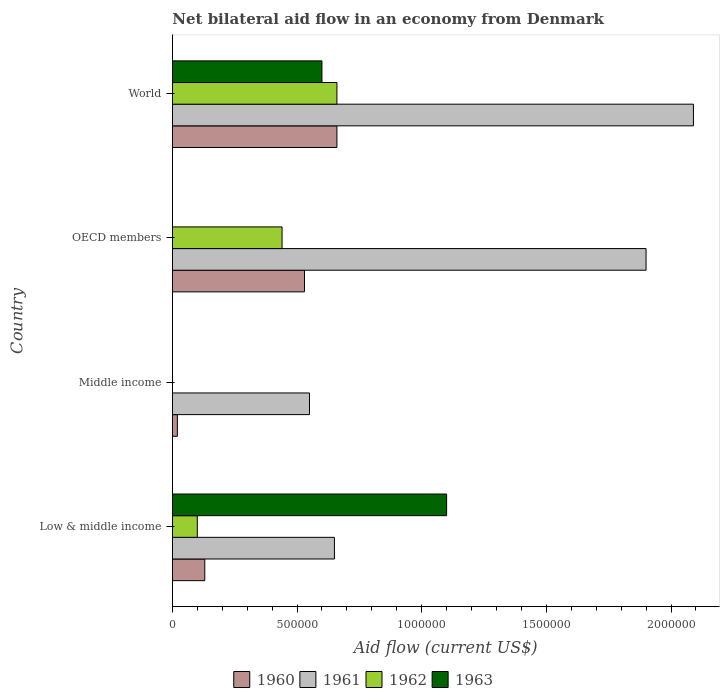What is the net bilateral aid flow in 1961 in OECD members?
Your response must be concise. 1.90e+06. Across all countries, what is the maximum net bilateral aid flow in 1963?
Provide a succinct answer. 1.10e+06. What is the total net bilateral aid flow in 1962 in the graph?
Your response must be concise. 1.20e+06. What is the difference between the net bilateral aid flow in 1961 in Middle income and that in World?
Your response must be concise. -1.54e+06. What is the average net bilateral aid flow in 1961 per country?
Make the answer very short. 1.30e+06. What is the difference between the net bilateral aid flow in 1963 and net bilateral aid flow in 1960 in Low & middle income?
Offer a very short reply. 9.70e+05. What is the ratio of the net bilateral aid flow in 1961 in Middle income to that in OECD members?
Provide a succinct answer. 0.29. What is the difference between the highest and the second highest net bilateral aid flow in 1961?
Offer a terse response. 1.90e+05. What is the difference between the highest and the lowest net bilateral aid flow in 1960?
Your answer should be very brief. 6.40e+05. Is the sum of the net bilateral aid flow in 1960 in Low & middle income and OECD members greater than the maximum net bilateral aid flow in 1961 across all countries?
Provide a succinct answer. No. How many bars are there?
Give a very brief answer. 13. How many countries are there in the graph?
Give a very brief answer. 4. Are the values on the major ticks of X-axis written in scientific E-notation?
Your response must be concise. No. Does the graph contain any zero values?
Make the answer very short. Yes. Where does the legend appear in the graph?
Your answer should be very brief. Bottom center. What is the title of the graph?
Ensure brevity in your answer.  Net bilateral aid flow in an economy from Denmark. What is the Aid flow (current US$) in 1961 in Low & middle income?
Offer a terse response. 6.50e+05. What is the Aid flow (current US$) in 1963 in Low & middle income?
Give a very brief answer. 1.10e+06. What is the Aid flow (current US$) in 1960 in Middle income?
Provide a succinct answer. 2.00e+04. What is the Aid flow (current US$) in 1960 in OECD members?
Provide a short and direct response. 5.30e+05. What is the Aid flow (current US$) of 1961 in OECD members?
Your answer should be compact. 1.90e+06. What is the Aid flow (current US$) in 1961 in World?
Your answer should be compact. 2.09e+06. What is the Aid flow (current US$) of 1962 in World?
Keep it short and to the point. 6.60e+05. What is the Aid flow (current US$) of 1963 in World?
Your response must be concise. 6.00e+05. Across all countries, what is the maximum Aid flow (current US$) in 1961?
Your answer should be very brief. 2.09e+06. Across all countries, what is the maximum Aid flow (current US$) of 1962?
Offer a very short reply. 6.60e+05. Across all countries, what is the maximum Aid flow (current US$) in 1963?
Make the answer very short. 1.10e+06. Across all countries, what is the minimum Aid flow (current US$) in 1960?
Offer a very short reply. 2.00e+04. Across all countries, what is the minimum Aid flow (current US$) in 1961?
Your answer should be compact. 5.50e+05. Across all countries, what is the minimum Aid flow (current US$) of 1962?
Your response must be concise. 0. Across all countries, what is the minimum Aid flow (current US$) in 1963?
Offer a very short reply. 0. What is the total Aid flow (current US$) of 1960 in the graph?
Your answer should be compact. 1.34e+06. What is the total Aid flow (current US$) of 1961 in the graph?
Your response must be concise. 5.19e+06. What is the total Aid flow (current US$) in 1962 in the graph?
Your response must be concise. 1.20e+06. What is the total Aid flow (current US$) in 1963 in the graph?
Your response must be concise. 1.70e+06. What is the difference between the Aid flow (current US$) in 1960 in Low & middle income and that in Middle income?
Ensure brevity in your answer.  1.10e+05. What is the difference between the Aid flow (current US$) of 1960 in Low & middle income and that in OECD members?
Provide a short and direct response. -4.00e+05. What is the difference between the Aid flow (current US$) in 1961 in Low & middle income and that in OECD members?
Ensure brevity in your answer.  -1.25e+06. What is the difference between the Aid flow (current US$) of 1960 in Low & middle income and that in World?
Provide a succinct answer. -5.30e+05. What is the difference between the Aid flow (current US$) of 1961 in Low & middle income and that in World?
Your answer should be very brief. -1.44e+06. What is the difference between the Aid flow (current US$) in 1962 in Low & middle income and that in World?
Your response must be concise. -5.60e+05. What is the difference between the Aid flow (current US$) of 1963 in Low & middle income and that in World?
Your answer should be compact. 5.00e+05. What is the difference between the Aid flow (current US$) of 1960 in Middle income and that in OECD members?
Your response must be concise. -5.10e+05. What is the difference between the Aid flow (current US$) in 1961 in Middle income and that in OECD members?
Make the answer very short. -1.35e+06. What is the difference between the Aid flow (current US$) of 1960 in Middle income and that in World?
Provide a succinct answer. -6.40e+05. What is the difference between the Aid flow (current US$) of 1961 in Middle income and that in World?
Offer a very short reply. -1.54e+06. What is the difference between the Aid flow (current US$) in 1960 in OECD members and that in World?
Provide a short and direct response. -1.30e+05. What is the difference between the Aid flow (current US$) of 1960 in Low & middle income and the Aid flow (current US$) of 1961 in Middle income?
Your response must be concise. -4.20e+05. What is the difference between the Aid flow (current US$) in 1960 in Low & middle income and the Aid flow (current US$) in 1961 in OECD members?
Your response must be concise. -1.77e+06. What is the difference between the Aid flow (current US$) in 1960 in Low & middle income and the Aid flow (current US$) in 1962 in OECD members?
Give a very brief answer. -3.10e+05. What is the difference between the Aid flow (current US$) of 1961 in Low & middle income and the Aid flow (current US$) of 1962 in OECD members?
Ensure brevity in your answer.  2.10e+05. What is the difference between the Aid flow (current US$) of 1960 in Low & middle income and the Aid flow (current US$) of 1961 in World?
Give a very brief answer. -1.96e+06. What is the difference between the Aid flow (current US$) in 1960 in Low & middle income and the Aid flow (current US$) in 1962 in World?
Your answer should be compact. -5.30e+05. What is the difference between the Aid flow (current US$) in 1960 in Low & middle income and the Aid flow (current US$) in 1963 in World?
Give a very brief answer. -4.70e+05. What is the difference between the Aid flow (current US$) of 1962 in Low & middle income and the Aid flow (current US$) of 1963 in World?
Give a very brief answer. -5.00e+05. What is the difference between the Aid flow (current US$) in 1960 in Middle income and the Aid flow (current US$) in 1961 in OECD members?
Make the answer very short. -1.88e+06. What is the difference between the Aid flow (current US$) of 1960 in Middle income and the Aid flow (current US$) of 1962 in OECD members?
Make the answer very short. -4.20e+05. What is the difference between the Aid flow (current US$) of 1961 in Middle income and the Aid flow (current US$) of 1962 in OECD members?
Ensure brevity in your answer.  1.10e+05. What is the difference between the Aid flow (current US$) of 1960 in Middle income and the Aid flow (current US$) of 1961 in World?
Keep it short and to the point. -2.07e+06. What is the difference between the Aid flow (current US$) of 1960 in Middle income and the Aid flow (current US$) of 1962 in World?
Offer a very short reply. -6.40e+05. What is the difference between the Aid flow (current US$) of 1960 in Middle income and the Aid flow (current US$) of 1963 in World?
Provide a succinct answer. -5.80e+05. What is the difference between the Aid flow (current US$) in 1961 in Middle income and the Aid flow (current US$) in 1962 in World?
Your response must be concise. -1.10e+05. What is the difference between the Aid flow (current US$) of 1961 in Middle income and the Aid flow (current US$) of 1963 in World?
Offer a terse response. -5.00e+04. What is the difference between the Aid flow (current US$) in 1960 in OECD members and the Aid flow (current US$) in 1961 in World?
Give a very brief answer. -1.56e+06. What is the difference between the Aid flow (current US$) of 1960 in OECD members and the Aid flow (current US$) of 1962 in World?
Provide a succinct answer. -1.30e+05. What is the difference between the Aid flow (current US$) in 1960 in OECD members and the Aid flow (current US$) in 1963 in World?
Offer a terse response. -7.00e+04. What is the difference between the Aid flow (current US$) of 1961 in OECD members and the Aid flow (current US$) of 1962 in World?
Provide a succinct answer. 1.24e+06. What is the difference between the Aid flow (current US$) of 1961 in OECD members and the Aid flow (current US$) of 1963 in World?
Ensure brevity in your answer.  1.30e+06. What is the average Aid flow (current US$) of 1960 per country?
Make the answer very short. 3.35e+05. What is the average Aid flow (current US$) in 1961 per country?
Your response must be concise. 1.30e+06. What is the average Aid flow (current US$) in 1962 per country?
Make the answer very short. 3.00e+05. What is the average Aid flow (current US$) of 1963 per country?
Make the answer very short. 4.25e+05. What is the difference between the Aid flow (current US$) in 1960 and Aid flow (current US$) in 1961 in Low & middle income?
Offer a terse response. -5.20e+05. What is the difference between the Aid flow (current US$) in 1960 and Aid flow (current US$) in 1963 in Low & middle income?
Offer a terse response. -9.70e+05. What is the difference between the Aid flow (current US$) in 1961 and Aid flow (current US$) in 1962 in Low & middle income?
Your response must be concise. 5.50e+05. What is the difference between the Aid flow (current US$) in 1961 and Aid flow (current US$) in 1963 in Low & middle income?
Offer a terse response. -4.50e+05. What is the difference between the Aid flow (current US$) of 1960 and Aid flow (current US$) of 1961 in Middle income?
Keep it short and to the point. -5.30e+05. What is the difference between the Aid flow (current US$) in 1960 and Aid flow (current US$) in 1961 in OECD members?
Ensure brevity in your answer.  -1.37e+06. What is the difference between the Aid flow (current US$) in 1961 and Aid flow (current US$) in 1962 in OECD members?
Ensure brevity in your answer.  1.46e+06. What is the difference between the Aid flow (current US$) in 1960 and Aid flow (current US$) in 1961 in World?
Offer a terse response. -1.43e+06. What is the difference between the Aid flow (current US$) in 1961 and Aid flow (current US$) in 1962 in World?
Ensure brevity in your answer.  1.43e+06. What is the difference between the Aid flow (current US$) in 1961 and Aid flow (current US$) in 1963 in World?
Make the answer very short. 1.49e+06. What is the difference between the Aid flow (current US$) in 1962 and Aid flow (current US$) in 1963 in World?
Give a very brief answer. 6.00e+04. What is the ratio of the Aid flow (current US$) in 1960 in Low & middle income to that in Middle income?
Your response must be concise. 6.5. What is the ratio of the Aid flow (current US$) of 1961 in Low & middle income to that in Middle income?
Keep it short and to the point. 1.18. What is the ratio of the Aid flow (current US$) in 1960 in Low & middle income to that in OECD members?
Keep it short and to the point. 0.25. What is the ratio of the Aid flow (current US$) of 1961 in Low & middle income to that in OECD members?
Offer a very short reply. 0.34. What is the ratio of the Aid flow (current US$) of 1962 in Low & middle income to that in OECD members?
Make the answer very short. 0.23. What is the ratio of the Aid flow (current US$) of 1960 in Low & middle income to that in World?
Your answer should be very brief. 0.2. What is the ratio of the Aid flow (current US$) in 1961 in Low & middle income to that in World?
Offer a very short reply. 0.31. What is the ratio of the Aid flow (current US$) of 1962 in Low & middle income to that in World?
Your answer should be very brief. 0.15. What is the ratio of the Aid flow (current US$) of 1963 in Low & middle income to that in World?
Ensure brevity in your answer.  1.83. What is the ratio of the Aid flow (current US$) of 1960 in Middle income to that in OECD members?
Provide a short and direct response. 0.04. What is the ratio of the Aid flow (current US$) in 1961 in Middle income to that in OECD members?
Provide a succinct answer. 0.29. What is the ratio of the Aid flow (current US$) of 1960 in Middle income to that in World?
Make the answer very short. 0.03. What is the ratio of the Aid flow (current US$) in 1961 in Middle income to that in World?
Offer a very short reply. 0.26. What is the ratio of the Aid flow (current US$) in 1960 in OECD members to that in World?
Provide a short and direct response. 0.8. What is the difference between the highest and the lowest Aid flow (current US$) of 1960?
Ensure brevity in your answer.  6.40e+05. What is the difference between the highest and the lowest Aid flow (current US$) in 1961?
Your answer should be compact. 1.54e+06. What is the difference between the highest and the lowest Aid flow (current US$) of 1962?
Provide a short and direct response. 6.60e+05. What is the difference between the highest and the lowest Aid flow (current US$) of 1963?
Your answer should be compact. 1.10e+06. 